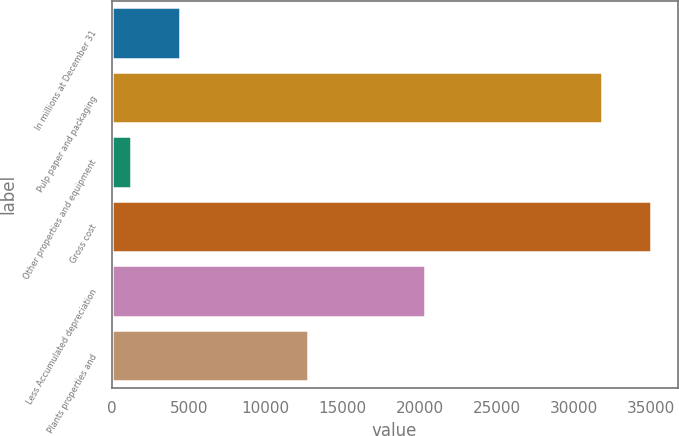<chart> <loc_0><loc_0><loc_500><loc_500><bar_chart><fcel>In millions at December 31<fcel>Pulp paper and packaging<fcel>Other properties and equipment<fcel>Gross cost<fcel>Less Accumulated depreciation<fcel>Plants properties and<nl><fcel>4443.5<fcel>31805<fcel>1263<fcel>34985.5<fcel>20340<fcel>12728<nl></chart> 